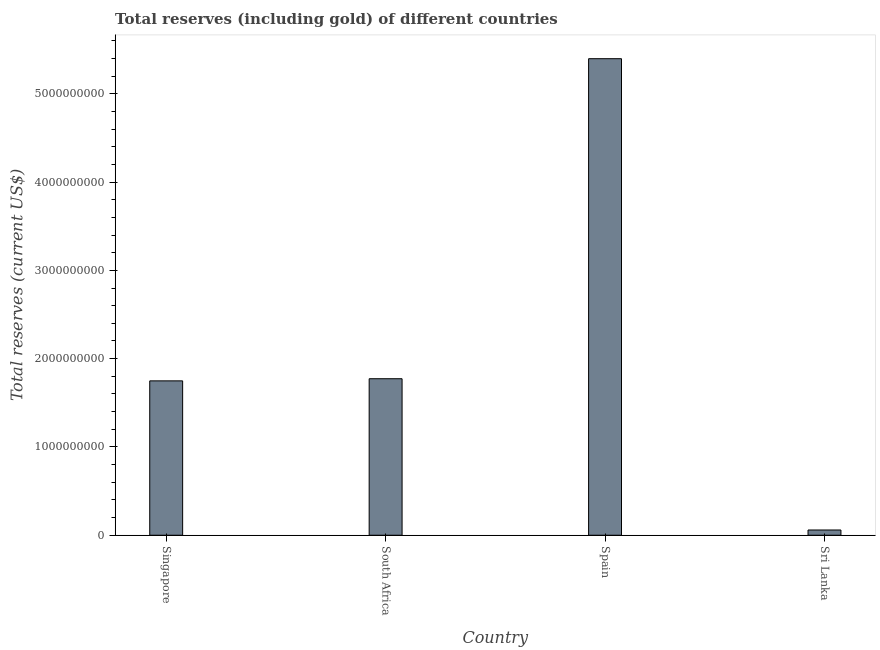Does the graph contain any zero values?
Ensure brevity in your answer.  No. Does the graph contain grids?
Offer a very short reply. No. What is the title of the graph?
Provide a short and direct response. Total reserves (including gold) of different countries. What is the label or title of the X-axis?
Offer a very short reply. Country. What is the label or title of the Y-axis?
Your answer should be very brief. Total reserves (current US$). What is the total reserves (including gold) in South Africa?
Offer a very short reply. 1.77e+09. Across all countries, what is the maximum total reserves (including gold)?
Provide a short and direct response. 5.40e+09. Across all countries, what is the minimum total reserves (including gold)?
Offer a terse response. 5.95e+07. In which country was the total reserves (including gold) maximum?
Keep it short and to the point. Spain. In which country was the total reserves (including gold) minimum?
Give a very brief answer. Sri Lanka. What is the sum of the total reserves (including gold)?
Your response must be concise. 8.98e+09. What is the difference between the total reserves (including gold) in South Africa and Sri Lanka?
Offer a terse response. 1.71e+09. What is the average total reserves (including gold) per country?
Your answer should be compact. 2.24e+09. What is the median total reserves (including gold)?
Keep it short and to the point. 1.76e+09. What is the ratio of the total reserves (including gold) in Singapore to that in Sri Lanka?
Your answer should be very brief. 29.4. What is the difference between the highest and the second highest total reserves (including gold)?
Offer a terse response. 3.62e+09. What is the difference between the highest and the lowest total reserves (including gold)?
Ensure brevity in your answer.  5.34e+09. In how many countries, is the total reserves (including gold) greater than the average total reserves (including gold) taken over all countries?
Provide a short and direct response. 1. How many bars are there?
Your answer should be very brief. 4. What is the difference between two consecutive major ticks on the Y-axis?
Provide a short and direct response. 1.00e+09. What is the Total reserves (current US$) of Singapore?
Offer a very short reply. 1.75e+09. What is the Total reserves (current US$) of South Africa?
Ensure brevity in your answer.  1.77e+09. What is the Total reserves (current US$) of Spain?
Keep it short and to the point. 5.40e+09. What is the Total reserves (current US$) of Sri Lanka?
Your answer should be compact. 5.95e+07. What is the difference between the Total reserves (current US$) in Singapore and South Africa?
Provide a succinct answer. -2.42e+07. What is the difference between the Total reserves (current US$) in Singapore and Spain?
Offer a very short reply. -3.65e+09. What is the difference between the Total reserves (current US$) in Singapore and Sri Lanka?
Provide a succinct answer. 1.69e+09. What is the difference between the Total reserves (current US$) in South Africa and Spain?
Your answer should be very brief. -3.62e+09. What is the difference between the Total reserves (current US$) in South Africa and Sri Lanka?
Keep it short and to the point. 1.71e+09. What is the difference between the Total reserves (current US$) in Spain and Sri Lanka?
Provide a short and direct response. 5.34e+09. What is the ratio of the Total reserves (current US$) in Singapore to that in South Africa?
Provide a succinct answer. 0.99. What is the ratio of the Total reserves (current US$) in Singapore to that in Spain?
Keep it short and to the point. 0.32. What is the ratio of the Total reserves (current US$) in Singapore to that in Sri Lanka?
Your answer should be compact. 29.4. What is the ratio of the Total reserves (current US$) in South Africa to that in Spain?
Ensure brevity in your answer.  0.33. What is the ratio of the Total reserves (current US$) in South Africa to that in Sri Lanka?
Make the answer very short. 29.81. What is the ratio of the Total reserves (current US$) in Spain to that in Sri Lanka?
Offer a terse response. 90.76. 